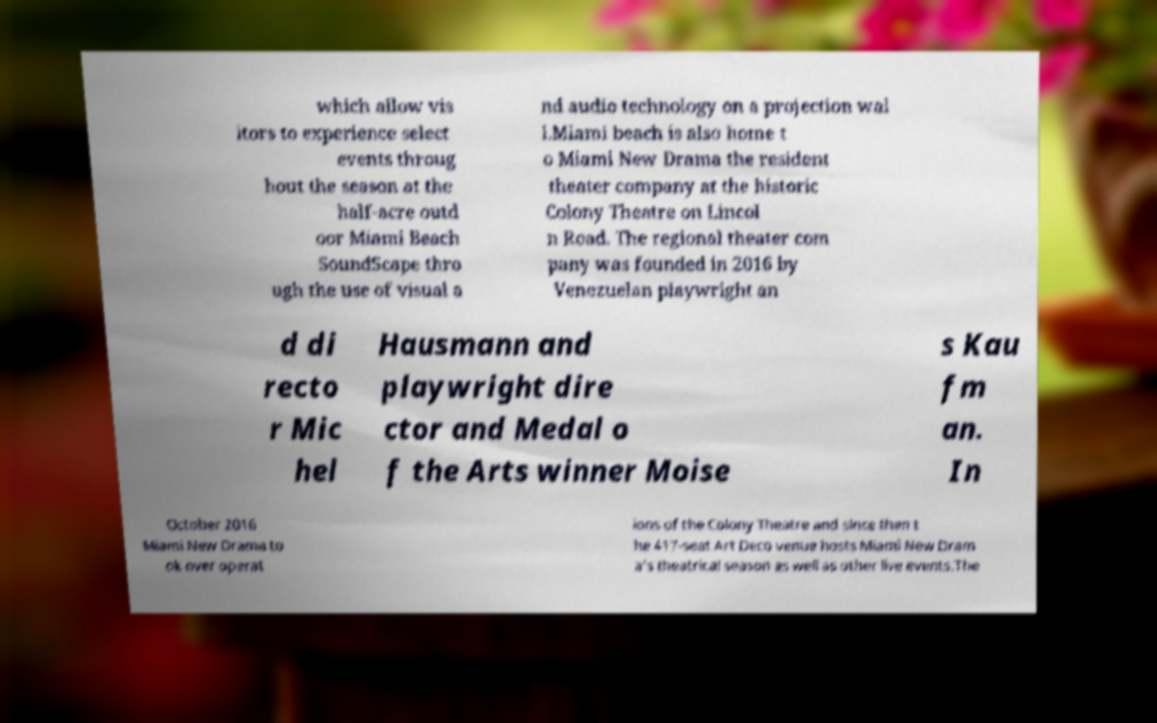There's text embedded in this image that I need extracted. Can you transcribe it verbatim? which allow vis itors to experience select events throug hout the season at the half-acre outd oor Miami Beach SoundScape thro ugh the use of visual a nd audio technology on a projection wal l.Miami beach is also home t o Miami New Drama the resident theater company at the historic Colony Theatre on Lincol n Road. The regional theater com pany was founded in 2016 by Venezuelan playwright an d di recto r Mic hel Hausmann and playwright dire ctor and Medal o f the Arts winner Moise s Kau fm an. In October 2016 Miami New Drama to ok over operat ions of the Colony Theatre and since then t he 417-seat Art Deco venue hosts Miami New Dram a's theatrical season as well as other live events.The 